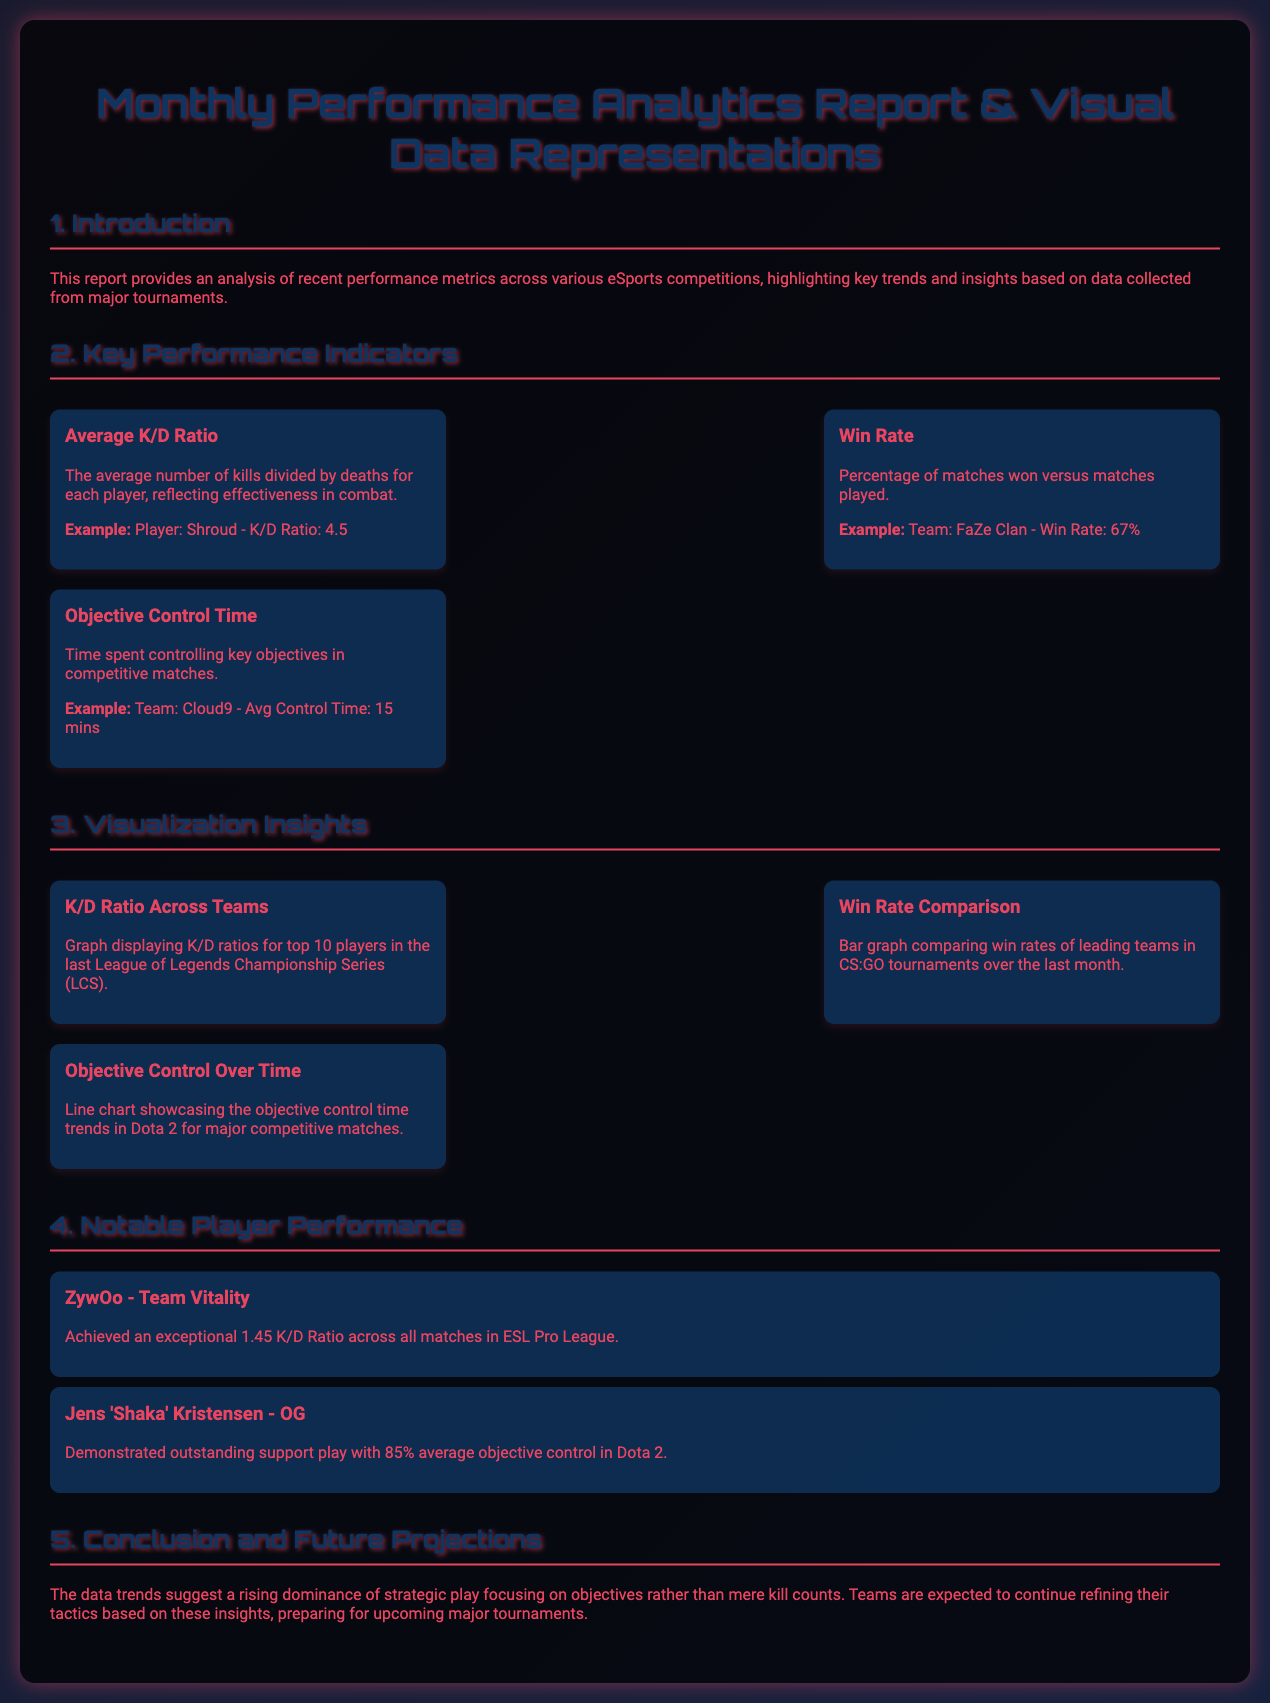What is the main focus of this report? The report focuses on analyzing recent performance metrics across various eSports competitions.
Answer: Performance metrics What was Shroud's K/D ratio? The document provides an example of Shroud's K/D ratio as 4.5.
Answer: 4.5 What is the win rate of FaZe Clan? According to the report, FaZe Clan has a win rate of 67%.
Answer: 67% What time does Cloud9 average for objective control? The document states that Cloud9 has an average control time of 15 minutes.
Answer: 15 mins Which player achieved a 1.45 K/D ratio? The report mentions ZywOo from Team Vitality achieved a 1.45 K/D ratio.
Answer: ZywOo Which game did Jens 'Shaka' Kristensen represent? Jens 'Shaka' Kristensen represented OG in Dota 2.
Answer: OG What trend does the data suggest for strategic play? The data suggests a rising dominance of strategic play focusing on objectives.
Answer: Strategic play focusing on objectives What type of graph compares win rates of teams? The report mentions a bar graph comparing win rates of teams in CS:GO tournaments.
Answer: Bar graph What does the K/D Ratio graph represent? The K/D Ratio graph displays K/D ratios for the top 10 players in the last League of Legends Championship Series.
Answer: Top 10 players in LCS 